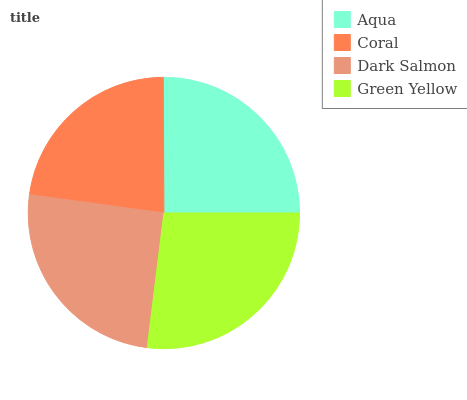Is Coral the minimum?
Answer yes or no. Yes. Is Green Yellow the maximum?
Answer yes or no. Yes. Is Dark Salmon the minimum?
Answer yes or no. No. Is Dark Salmon the maximum?
Answer yes or no. No. Is Dark Salmon greater than Coral?
Answer yes or no. Yes. Is Coral less than Dark Salmon?
Answer yes or no. Yes. Is Coral greater than Dark Salmon?
Answer yes or no. No. Is Dark Salmon less than Coral?
Answer yes or no. No. Is Dark Salmon the high median?
Answer yes or no. Yes. Is Aqua the low median?
Answer yes or no. Yes. Is Coral the high median?
Answer yes or no. No. Is Green Yellow the low median?
Answer yes or no. No. 